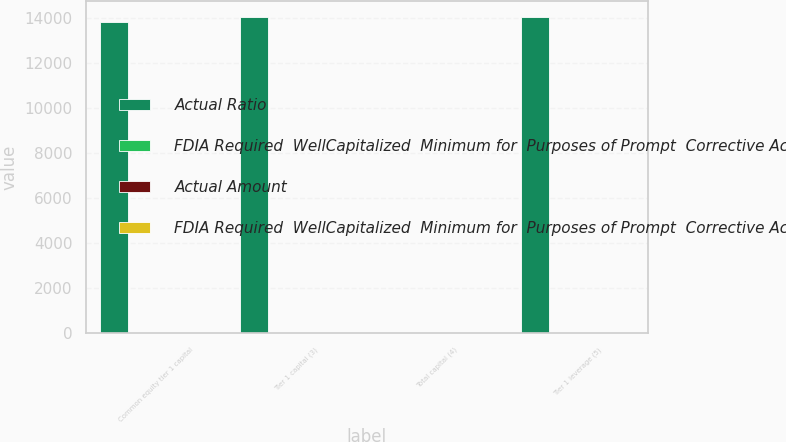<chart> <loc_0><loc_0><loc_500><loc_500><stacked_bar_chart><ecel><fcel>Common equity tier 1 capital<fcel>Tier 1 capital (3)<fcel>Total capital (4)<fcel>Tier 1 leverage (5)<nl><fcel>Actual Ratio<fcel>13822<fcel>14069<fcel>9.9<fcel>14069<nl><fcel>FDIA Required  WellCapitalized  Minimum for  Purposes of Prompt  Corrective Action 9<fcel>11.2<fcel>11.4<fcel>14<fcel>9.9<nl><fcel>Actual Amount<fcel>5.1<fcel>6.6<fcel>8.6<fcel>4<nl><fcel>FDIA Required  WellCapitalized  Minimum for  Purposes of Prompt  Corrective Action  9<fcel>6.5<fcel>8<fcel>10<fcel>5<nl></chart> 